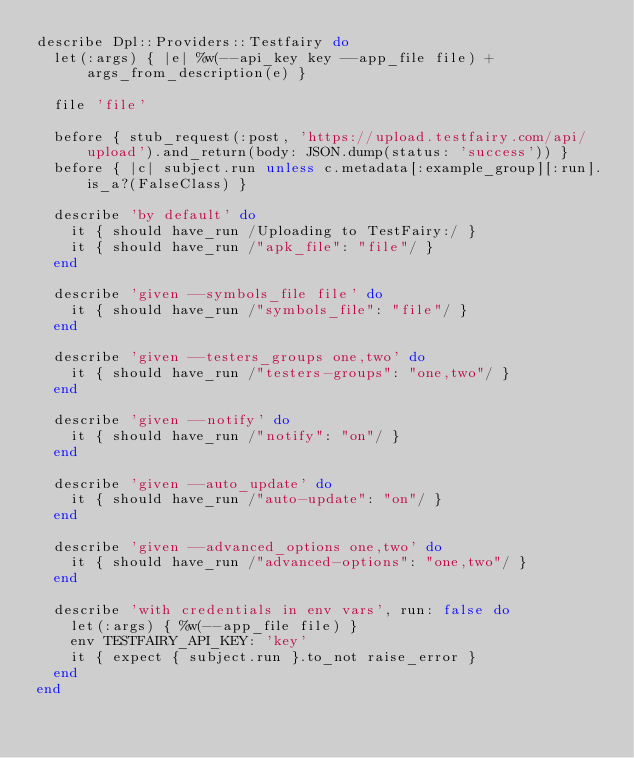Convert code to text. <code><loc_0><loc_0><loc_500><loc_500><_Ruby_>describe Dpl::Providers::Testfairy do
  let(:args) { |e| %w(--api_key key --app_file file) + args_from_description(e) }

  file 'file'

  before { stub_request(:post, 'https://upload.testfairy.com/api/upload').and_return(body: JSON.dump(status: 'success')) }
  before { |c| subject.run unless c.metadata[:example_group][:run].is_a?(FalseClass) }

  describe 'by default' do
    it { should have_run /Uploading to TestFairy:/ }
    it { should have_run /"apk_file": "file"/ }
  end

  describe 'given --symbols_file file' do
    it { should have_run /"symbols_file": "file"/ }
  end

  describe 'given --testers_groups one,two' do
    it { should have_run /"testers-groups": "one,two"/ }
  end

  describe 'given --notify' do
    it { should have_run /"notify": "on"/ }
  end

  describe 'given --auto_update' do
    it { should have_run /"auto-update": "on"/ }
  end

  describe 'given --advanced_options one,two' do
    it { should have_run /"advanced-options": "one,two"/ }
  end

  describe 'with credentials in env vars', run: false do
    let(:args) { %w(--app_file file) }
    env TESTFAIRY_API_KEY: 'key'
    it { expect { subject.run }.to_not raise_error }
  end
end
</code> 